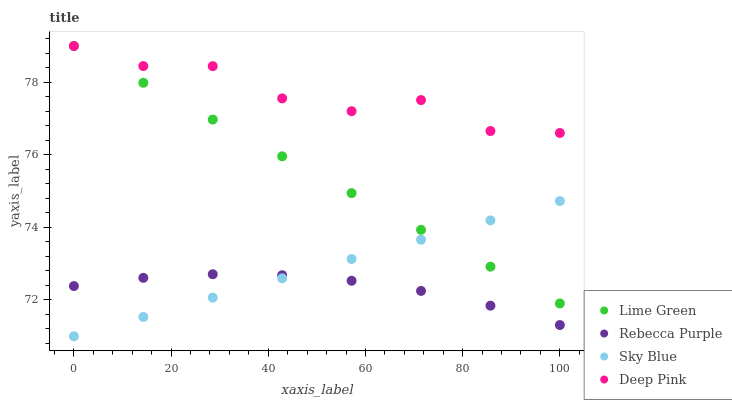Does Rebecca Purple have the minimum area under the curve?
Answer yes or no. Yes. Does Deep Pink have the maximum area under the curve?
Answer yes or no. Yes. Does Lime Green have the minimum area under the curve?
Answer yes or no. No. Does Lime Green have the maximum area under the curve?
Answer yes or no. No. Is Sky Blue the smoothest?
Answer yes or no. Yes. Is Deep Pink the roughest?
Answer yes or no. Yes. Is Lime Green the smoothest?
Answer yes or no. No. Is Lime Green the roughest?
Answer yes or no. No. Does Sky Blue have the lowest value?
Answer yes or no. Yes. Does Lime Green have the lowest value?
Answer yes or no. No. Does Lime Green have the highest value?
Answer yes or no. Yes. Does Rebecca Purple have the highest value?
Answer yes or no. No. Is Rebecca Purple less than Deep Pink?
Answer yes or no. Yes. Is Deep Pink greater than Sky Blue?
Answer yes or no. Yes. Does Lime Green intersect Sky Blue?
Answer yes or no. Yes. Is Lime Green less than Sky Blue?
Answer yes or no. No. Is Lime Green greater than Sky Blue?
Answer yes or no. No. Does Rebecca Purple intersect Deep Pink?
Answer yes or no. No. 